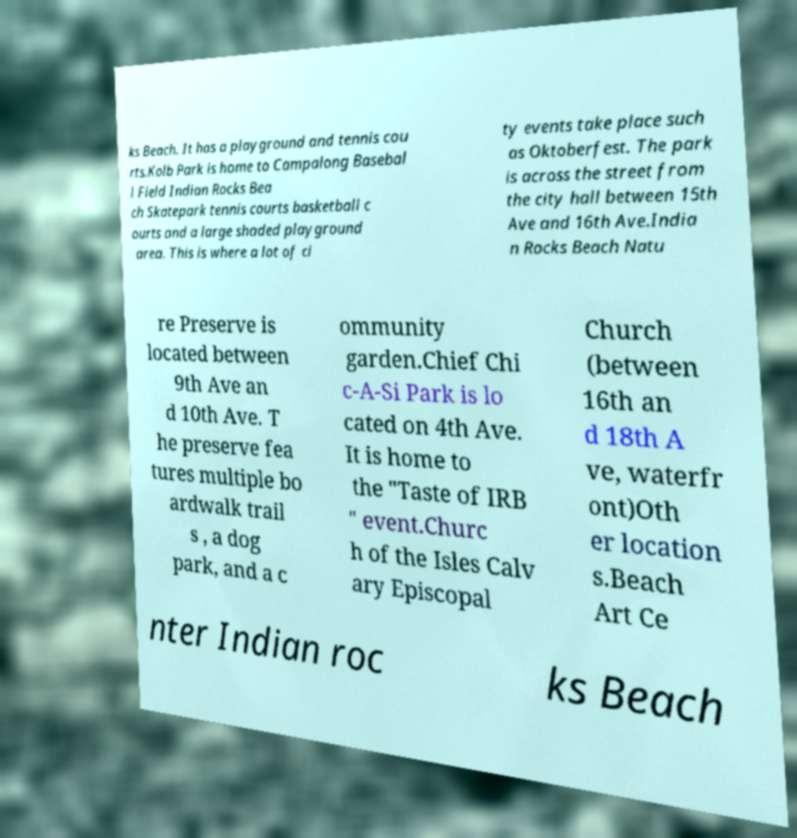Can you accurately transcribe the text from the provided image for me? ks Beach. It has a playground and tennis cou rts.Kolb Park is home to Campalong Basebal l Field Indian Rocks Bea ch Skatepark tennis courts basketball c ourts and a large shaded playground area. This is where a lot of ci ty events take place such as Oktoberfest. The park is across the street from the city hall between 15th Ave and 16th Ave.India n Rocks Beach Natu re Preserve is located between 9th Ave an d 10th Ave. T he preserve fea tures multiple bo ardwalk trail s , a dog park, and a c ommunity garden.Chief Chi c-A-Si Park is lo cated on 4th Ave. It is home to the "Taste of IRB " event.Churc h of the Isles Calv ary Episcopal Church (between 16th an d 18th A ve, waterfr ont)Oth er location s.Beach Art Ce nter Indian roc ks Beach 